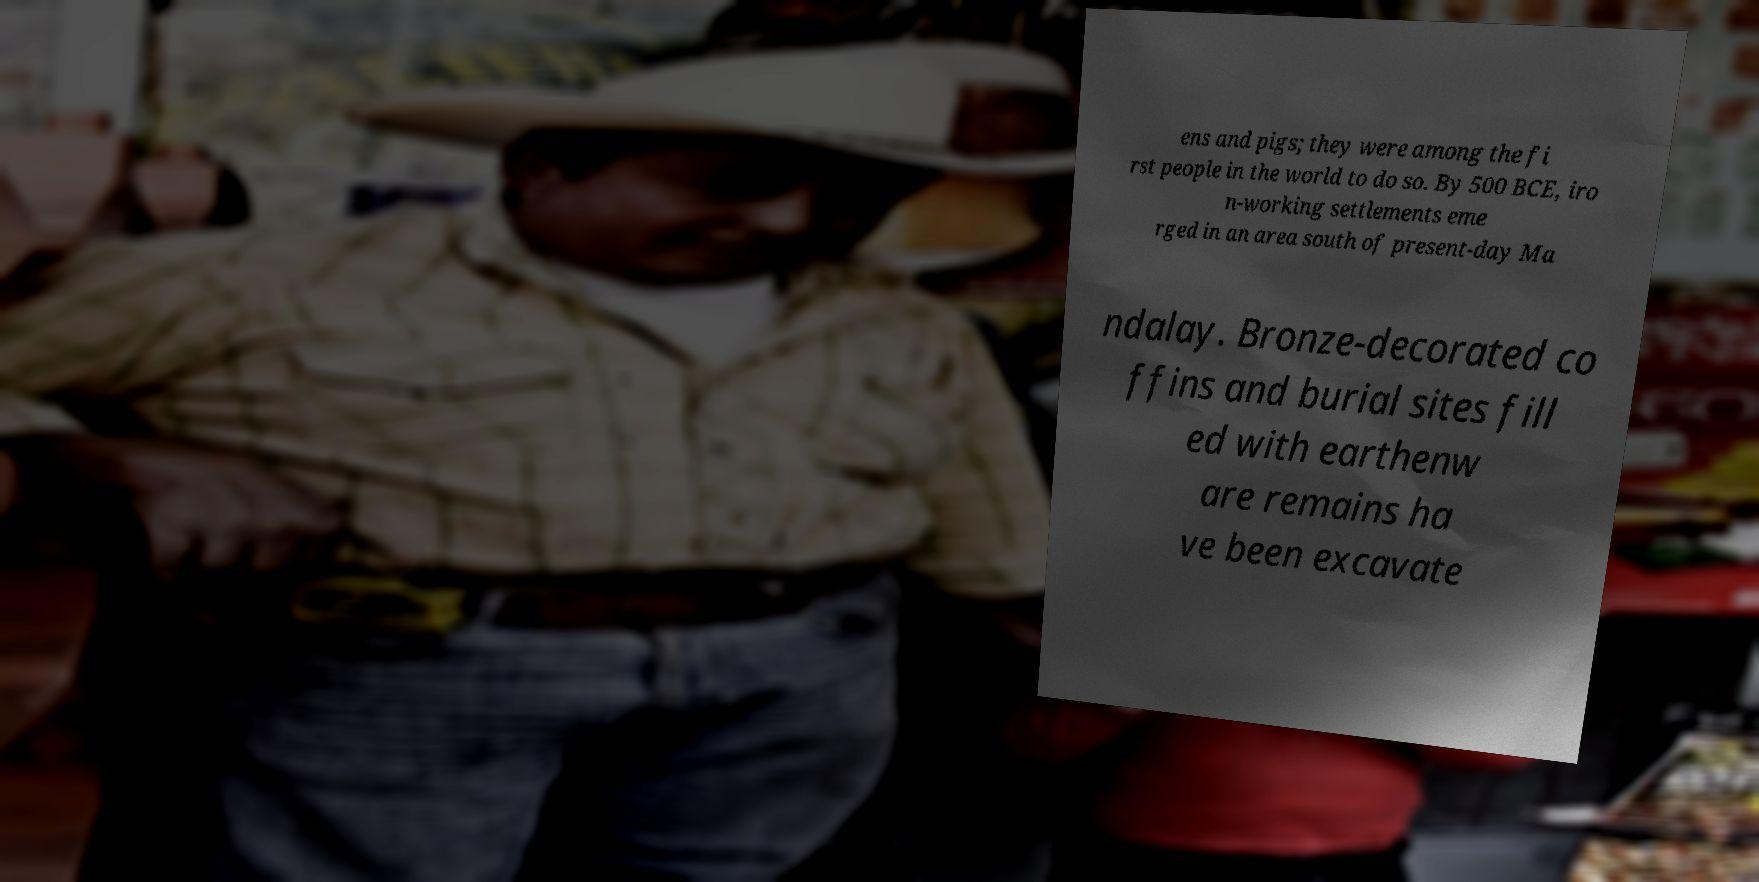There's text embedded in this image that I need extracted. Can you transcribe it verbatim? ens and pigs; they were among the fi rst people in the world to do so. By 500 BCE, iro n-working settlements eme rged in an area south of present-day Ma ndalay. Bronze-decorated co ffins and burial sites fill ed with earthenw are remains ha ve been excavate 